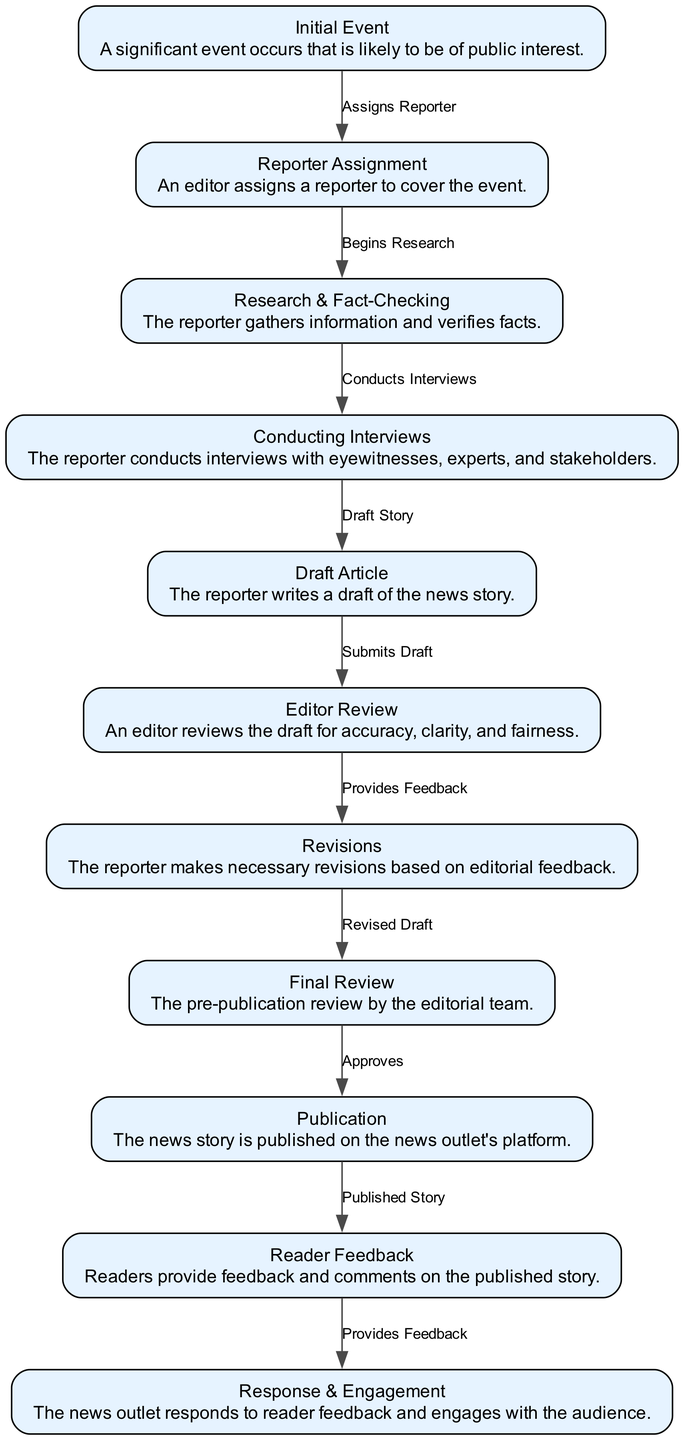What is the first step in the lifecycle of a news story? The first step, represented by the node "Initial Event", indicates that a significant event occurs that is deemed important for public interest. This sets the entire process in motion.
Answer: Initial Event How many nodes are in the diagram? By counting each distinct step in the lifecycle represented within the nodes, we find that there are 11 nodes detailing various stages of a news story from the event to reader engagement.
Answer: 11 What happens after the "Draft Article"? After the "Draft Article" step, the process moves to "Editor Review", where an editor assesses the draft before it can proceed further down the lifecycle.
Answer: Editor Review Which node follows "Research & Fact-Checking"? The "Interviews" step immediately follows "Research & Fact-Checking", indicating that the reporter conducts interviews after gathering relevant information.
Answer: Conducting Interviews What is the relationship between "Reader Feedback" and "Response & Engagement"? The relationship shows that "Reader Feedback" leads to "Response & Engagement", where the news outlet reacts to the feedback received from readers and interacts with them.
Answer: Provides Feedback In how many stages does the editing process occur? The editing process occurs in three stages: "Editor Review", "Revisions", and "Final Review", showcasing a structured approach to refining the news story before publication.
Answer: 3 What step comes immediately before "Publication"? The "Final Review" is the last step that occurs right before "Publication", ensuring that all content is approved for release to the public.
Answer: Final Review How does the lifecycle of a news story conclude? The lifecycle concludes with "Response & Engagement", where the news outlet interacts with readers based on the feedback received after publication.
Answer: Response & Engagement What is the primary function of the "Research & Fact-Checking" stage? The primary function of this stage is to gather information and verify facts, which is crucial for ensuring accuracy before further steps in the news reporting process.
Answer: Gather Information and Verify Facts 